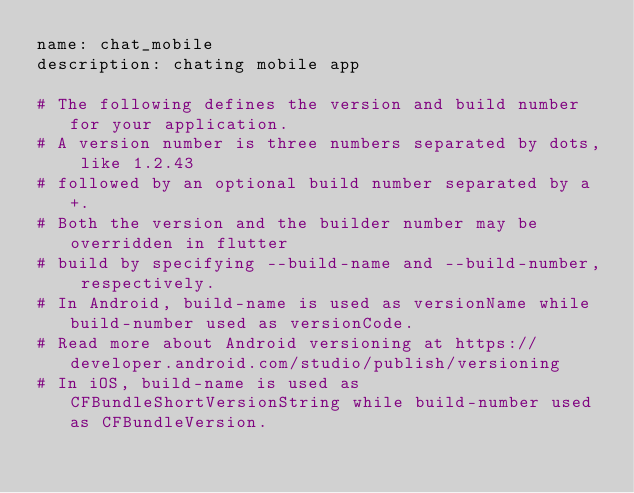<code> <loc_0><loc_0><loc_500><loc_500><_YAML_>name: chat_mobile
description: chating mobile app

# The following defines the version and build number for your application.
# A version number is three numbers separated by dots, like 1.2.43
# followed by an optional build number separated by a +.
# Both the version and the builder number may be overridden in flutter
# build by specifying --build-name and --build-number, respectively.
# In Android, build-name is used as versionName while build-number used as versionCode.
# Read more about Android versioning at https://developer.android.com/studio/publish/versioning
# In iOS, build-name is used as CFBundleShortVersionString while build-number used as CFBundleVersion.</code> 